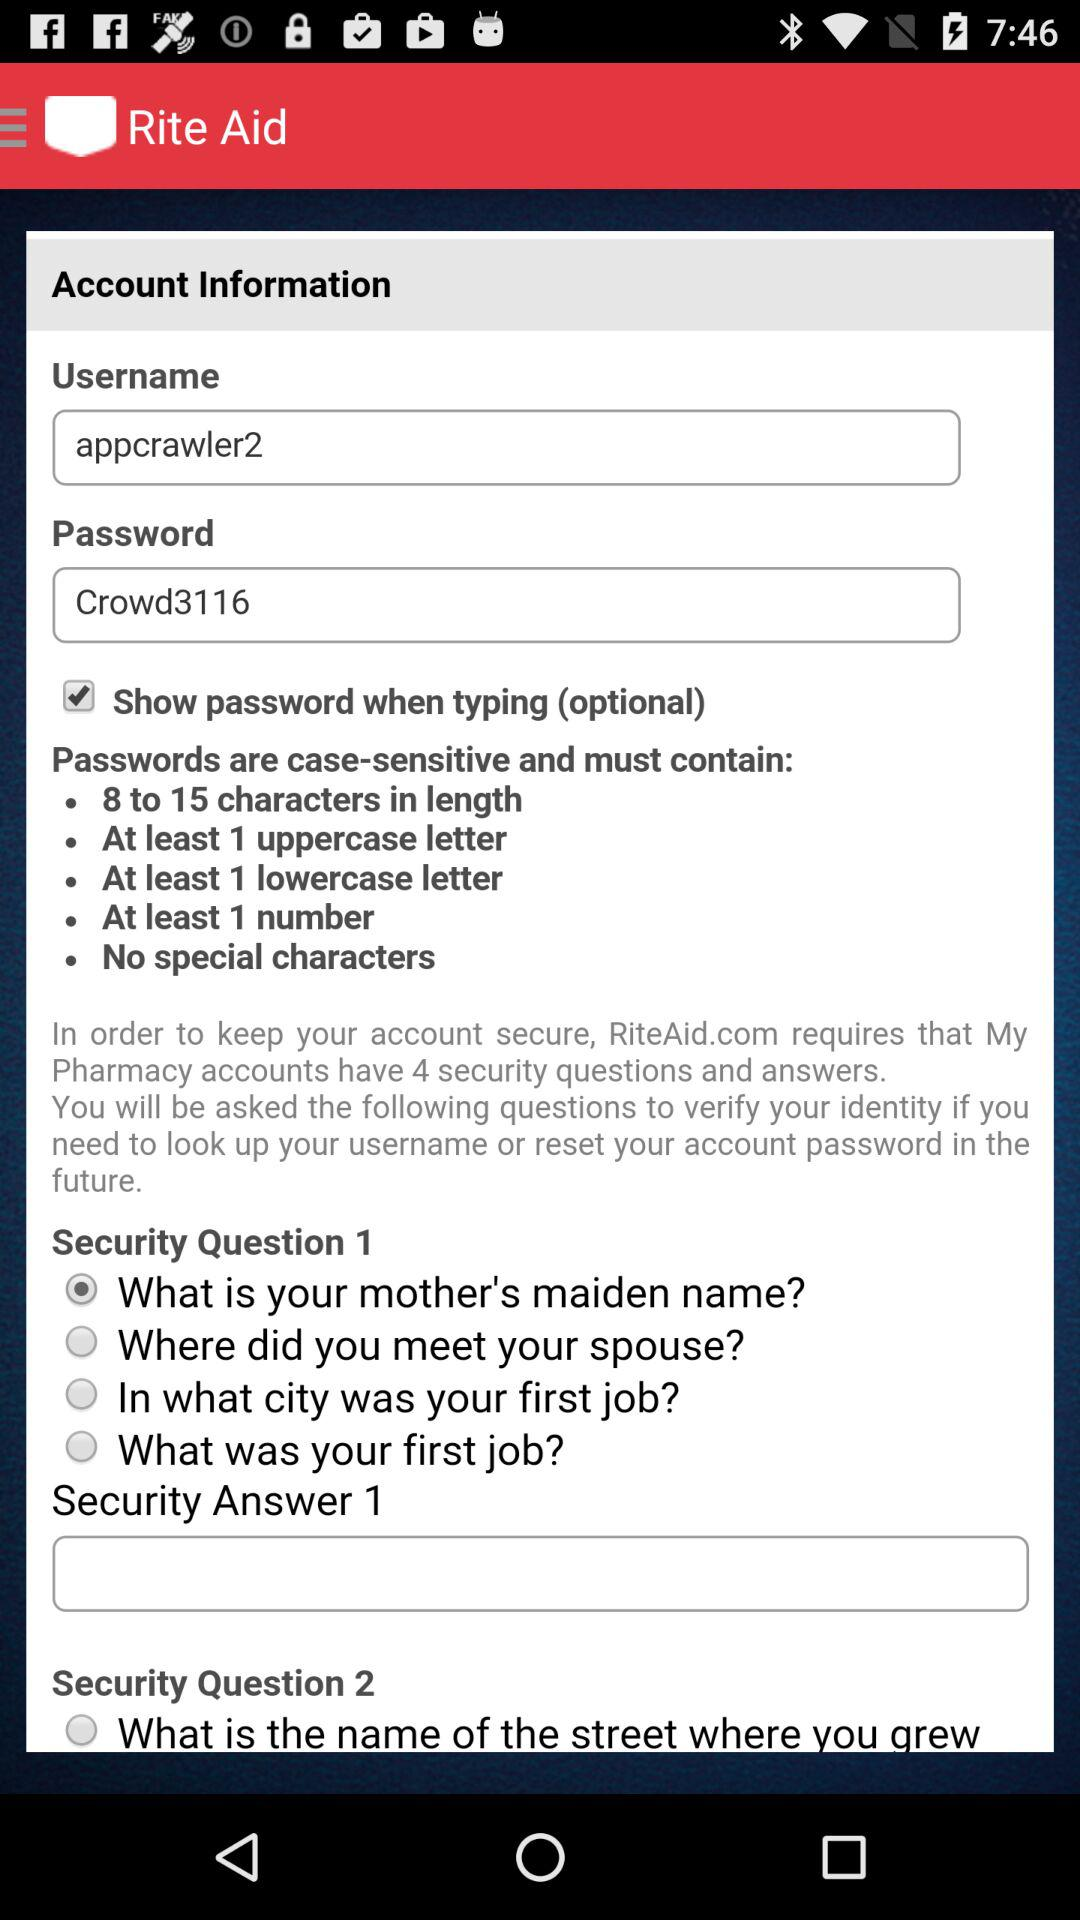How many uppercase letters are required? There is at least 1 uppercase letter required. 